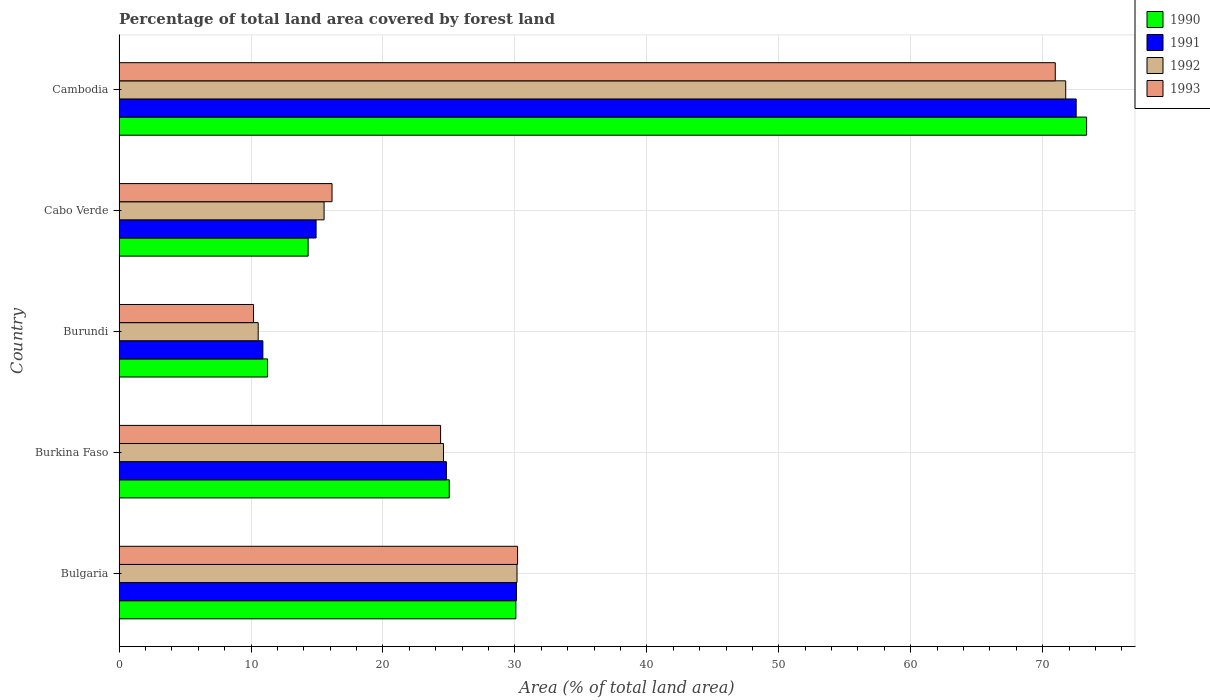How many different coloured bars are there?
Your answer should be compact. 4. What is the label of the 4th group of bars from the top?
Provide a short and direct response. Burkina Faso. In how many cases, is the number of bars for a given country not equal to the number of legend labels?
Ensure brevity in your answer.  0. What is the percentage of forest land in 1990 in Burundi?
Your answer should be very brief. 11.25. Across all countries, what is the maximum percentage of forest land in 1990?
Give a very brief answer. 73.33. Across all countries, what is the minimum percentage of forest land in 1992?
Offer a very short reply. 10.55. In which country was the percentage of forest land in 1993 maximum?
Keep it short and to the point. Cambodia. In which country was the percentage of forest land in 1991 minimum?
Ensure brevity in your answer.  Burundi. What is the total percentage of forest land in 1992 in the graph?
Your answer should be very brief. 152.58. What is the difference between the percentage of forest land in 1992 in Cabo Verde and that in Cambodia?
Offer a terse response. -56.21. What is the difference between the percentage of forest land in 1990 in Cabo Verde and the percentage of forest land in 1993 in Cambodia?
Make the answer very short. -56.62. What is the average percentage of forest land in 1990 per country?
Ensure brevity in your answer.  30.8. What is the difference between the percentage of forest land in 1993 and percentage of forest land in 1990 in Cabo Verde?
Your answer should be very brief. 1.81. What is the ratio of the percentage of forest land in 1990 in Cabo Verde to that in Cambodia?
Your answer should be very brief. 0.2. What is the difference between the highest and the second highest percentage of forest land in 1992?
Provide a short and direct response. 41.58. What is the difference between the highest and the lowest percentage of forest land in 1992?
Offer a terse response. 61.2. Is the sum of the percentage of forest land in 1993 in Burkina Faso and Cabo Verde greater than the maximum percentage of forest land in 1992 across all countries?
Your response must be concise. No. How many legend labels are there?
Your answer should be very brief. 4. How are the legend labels stacked?
Offer a terse response. Vertical. What is the title of the graph?
Offer a very short reply. Percentage of total land area covered by forest land. Does "1986" appear as one of the legend labels in the graph?
Provide a succinct answer. No. What is the label or title of the X-axis?
Provide a short and direct response. Area (% of total land area). What is the label or title of the Y-axis?
Provide a succinct answer. Country. What is the Area (% of total land area) of 1990 in Bulgaria?
Your answer should be compact. 30.07. What is the Area (% of total land area) in 1991 in Bulgaria?
Keep it short and to the point. 30.12. What is the Area (% of total land area) of 1992 in Bulgaria?
Your response must be concise. 30.16. What is the Area (% of total land area) of 1993 in Bulgaria?
Provide a succinct answer. 30.2. What is the Area (% of total land area) in 1990 in Burkina Faso?
Offer a very short reply. 25.03. What is the Area (% of total land area) in 1991 in Burkina Faso?
Your response must be concise. 24.81. What is the Area (% of total land area) of 1992 in Burkina Faso?
Make the answer very short. 24.59. What is the Area (% of total land area) in 1993 in Burkina Faso?
Provide a succinct answer. 24.37. What is the Area (% of total land area) of 1990 in Burundi?
Keep it short and to the point. 11.25. What is the Area (% of total land area) in 1991 in Burundi?
Make the answer very short. 10.9. What is the Area (% of total land area) in 1992 in Burundi?
Offer a very short reply. 10.55. What is the Area (% of total land area) in 1993 in Burundi?
Keep it short and to the point. 10.19. What is the Area (% of total land area) in 1990 in Cabo Verde?
Offer a very short reply. 14.33. What is the Area (% of total land area) of 1991 in Cabo Verde?
Provide a succinct answer. 14.93. What is the Area (% of total land area) of 1992 in Cabo Verde?
Offer a terse response. 15.54. What is the Area (% of total land area) in 1993 in Cabo Verde?
Offer a very short reply. 16.14. What is the Area (% of total land area) of 1990 in Cambodia?
Keep it short and to the point. 73.33. What is the Area (% of total land area) in 1991 in Cambodia?
Ensure brevity in your answer.  72.54. What is the Area (% of total land area) in 1992 in Cambodia?
Offer a terse response. 71.74. What is the Area (% of total land area) of 1993 in Cambodia?
Your response must be concise. 70.95. Across all countries, what is the maximum Area (% of total land area) in 1990?
Make the answer very short. 73.33. Across all countries, what is the maximum Area (% of total land area) in 1991?
Make the answer very short. 72.54. Across all countries, what is the maximum Area (% of total land area) in 1992?
Make the answer very short. 71.74. Across all countries, what is the maximum Area (% of total land area) of 1993?
Offer a very short reply. 70.95. Across all countries, what is the minimum Area (% of total land area) of 1990?
Your answer should be compact. 11.25. Across all countries, what is the minimum Area (% of total land area) of 1991?
Your answer should be very brief. 10.9. Across all countries, what is the minimum Area (% of total land area) in 1992?
Ensure brevity in your answer.  10.55. Across all countries, what is the minimum Area (% of total land area) in 1993?
Provide a short and direct response. 10.19. What is the total Area (% of total land area) of 1990 in the graph?
Your response must be concise. 154.01. What is the total Area (% of total land area) in 1991 in the graph?
Offer a very short reply. 153.29. What is the total Area (% of total land area) in 1992 in the graph?
Your answer should be very brief. 152.58. What is the total Area (% of total land area) in 1993 in the graph?
Offer a very short reply. 151.86. What is the difference between the Area (% of total land area) in 1990 in Bulgaria and that in Burkina Faso?
Ensure brevity in your answer.  5.05. What is the difference between the Area (% of total land area) of 1991 in Bulgaria and that in Burkina Faso?
Provide a short and direct response. 5.31. What is the difference between the Area (% of total land area) of 1992 in Bulgaria and that in Burkina Faso?
Offer a very short reply. 5.57. What is the difference between the Area (% of total land area) of 1993 in Bulgaria and that in Burkina Faso?
Your response must be concise. 5.83. What is the difference between the Area (% of total land area) in 1990 in Bulgaria and that in Burundi?
Keep it short and to the point. 18.82. What is the difference between the Area (% of total land area) of 1991 in Bulgaria and that in Burundi?
Offer a very short reply. 19.22. What is the difference between the Area (% of total land area) in 1992 in Bulgaria and that in Burundi?
Provide a succinct answer. 19.61. What is the difference between the Area (% of total land area) of 1993 in Bulgaria and that in Burundi?
Give a very brief answer. 20.01. What is the difference between the Area (% of total land area) of 1990 in Bulgaria and that in Cabo Verde?
Keep it short and to the point. 15.74. What is the difference between the Area (% of total land area) of 1991 in Bulgaria and that in Cabo Verde?
Your answer should be compact. 15.18. What is the difference between the Area (% of total land area) in 1992 in Bulgaria and that in Cabo Verde?
Ensure brevity in your answer.  14.62. What is the difference between the Area (% of total land area) in 1993 in Bulgaria and that in Cabo Verde?
Provide a succinct answer. 14.06. What is the difference between the Area (% of total land area) of 1990 in Bulgaria and that in Cambodia?
Provide a short and direct response. -43.26. What is the difference between the Area (% of total land area) in 1991 in Bulgaria and that in Cambodia?
Offer a very short reply. -42.42. What is the difference between the Area (% of total land area) of 1992 in Bulgaria and that in Cambodia?
Your answer should be compact. -41.58. What is the difference between the Area (% of total land area) in 1993 in Bulgaria and that in Cambodia?
Your answer should be compact. -40.75. What is the difference between the Area (% of total land area) in 1990 in Burkina Faso and that in Burundi?
Your answer should be compact. 13.77. What is the difference between the Area (% of total land area) of 1991 in Burkina Faso and that in Burundi?
Make the answer very short. 13.91. What is the difference between the Area (% of total land area) of 1992 in Burkina Faso and that in Burundi?
Your answer should be compact. 14.04. What is the difference between the Area (% of total land area) of 1993 in Burkina Faso and that in Burundi?
Give a very brief answer. 14.18. What is the difference between the Area (% of total land area) of 1990 in Burkina Faso and that in Cabo Verde?
Your response must be concise. 10.7. What is the difference between the Area (% of total land area) of 1991 in Burkina Faso and that in Cabo Verde?
Offer a terse response. 9.87. What is the difference between the Area (% of total land area) in 1992 in Burkina Faso and that in Cabo Verde?
Offer a very short reply. 9.05. What is the difference between the Area (% of total land area) of 1993 in Burkina Faso and that in Cabo Verde?
Provide a short and direct response. 8.23. What is the difference between the Area (% of total land area) in 1990 in Burkina Faso and that in Cambodia?
Keep it short and to the point. -48.3. What is the difference between the Area (% of total land area) in 1991 in Burkina Faso and that in Cambodia?
Keep it short and to the point. -47.73. What is the difference between the Area (% of total land area) in 1992 in Burkina Faso and that in Cambodia?
Keep it short and to the point. -47.16. What is the difference between the Area (% of total land area) of 1993 in Burkina Faso and that in Cambodia?
Ensure brevity in your answer.  -46.58. What is the difference between the Area (% of total land area) in 1990 in Burundi and that in Cabo Verde?
Give a very brief answer. -3.08. What is the difference between the Area (% of total land area) in 1991 in Burundi and that in Cabo Verde?
Give a very brief answer. -4.03. What is the difference between the Area (% of total land area) of 1992 in Burundi and that in Cabo Verde?
Your answer should be very brief. -4.99. What is the difference between the Area (% of total land area) of 1993 in Burundi and that in Cabo Verde?
Offer a terse response. -5.95. What is the difference between the Area (% of total land area) in 1990 in Burundi and that in Cambodia?
Provide a succinct answer. -62.07. What is the difference between the Area (% of total land area) of 1991 in Burundi and that in Cambodia?
Your answer should be very brief. -61.64. What is the difference between the Area (% of total land area) of 1992 in Burundi and that in Cambodia?
Ensure brevity in your answer.  -61.2. What is the difference between the Area (% of total land area) in 1993 in Burundi and that in Cambodia?
Ensure brevity in your answer.  -60.76. What is the difference between the Area (% of total land area) of 1990 in Cabo Verde and that in Cambodia?
Keep it short and to the point. -59. What is the difference between the Area (% of total land area) of 1991 in Cabo Verde and that in Cambodia?
Give a very brief answer. -57.6. What is the difference between the Area (% of total land area) in 1992 in Cabo Verde and that in Cambodia?
Your answer should be compact. -56.21. What is the difference between the Area (% of total land area) in 1993 in Cabo Verde and that in Cambodia?
Your answer should be compact. -54.81. What is the difference between the Area (% of total land area) of 1990 in Bulgaria and the Area (% of total land area) of 1991 in Burkina Faso?
Your answer should be compact. 5.27. What is the difference between the Area (% of total land area) in 1990 in Bulgaria and the Area (% of total land area) in 1992 in Burkina Faso?
Keep it short and to the point. 5.49. What is the difference between the Area (% of total land area) of 1990 in Bulgaria and the Area (% of total land area) of 1993 in Burkina Faso?
Provide a short and direct response. 5.7. What is the difference between the Area (% of total land area) of 1991 in Bulgaria and the Area (% of total land area) of 1992 in Burkina Faso?
Your answer should be compact. 5.53. What is the difference between the Area (% of total land area) in 1991 in Bulgaria and the Area (% of total land area) in 1993 in Burkina Faso?
Offer a terse response. 5.75. What is the difference between the Area (% of total land area) of 1992 in Bulgaria and the Area (% of total land area) of 1993 in Burkina Faso?
Provide a succinct answer. 5.79. What is the difference between the Area (% of total land area) in 1990 in Bulgaria and the Area (% of total land area) in 1991 in Burundi?
Your response must be concise. 19.17. What is the difference between the Area (% of total land area) of 1990 in Bulgaria and the Area (% of total land area) of 1992 in Burundi?
Provide a short and direct response. 19.53. What is the difference between the Area (% of total land area) in 1990 in Bulgaria and the Area (% of total land area) in 1993 in Burundi?
Make the answer very short. 19.88. What is the difference between the Area (% of total land area) in 1991 in Bulgaria and the Area (% of total land area) in 1992 in Burundi?
Your answer should be very brief. 19.57. What is the difference between the Area (% of total land area) in 1991 in Bulgaria and the Area (% of total land area) in 1993 in Burundi?
Keep it short and to the point. 19.93. What is the difference between the Area (% of total land area) in 1992 in Bulgaria and the Area (% of total land area) in 1993 in Burundi?
Your answer should be compact. 19.97. What is the difference between the Area (% of total land area) in 1990 in Bulgaria and the Area (% of total land area) in 1991 in Cabo Verde?
Provide a succinct answer. 15.14. What is the difference between the Area (% of total land area) in 1990 in Bulgaria and the Area (% of total land area) in 1992 in Cabo Verde?
Your response must be concise. 14.53. What is the difference between the Area (% of total land area) in 1990 in Bulgaria and the Area (% of total land area) in 1993 in Cabo Verde?
Give a very brief answer. 13.93. What is the difference between the Area (% of total land area) in 1991 in Bulgaria and the Area (% of total land area) in 1992 in Cabo Verde?
Ensure brevity in your answer.  14.58. What is the difference between the Area (% of total land area) of 1991 in Bulgaria and the Area (% of total land area) of 1993 in Cabo Verde?
Provide a short and direct response. 13.98. What is the difference between the Area (% of total land area) of 1992 in Bulgaria and the Area (% of total land area) of 1993 in Cabo Verde?
Your answer should be very brief. 14.02. What is the difference between the Area (% of total land area) in 1990 in Bulgaria and the Area (% of total land area) in 1991 in Cambodia?
Provide a short and direct response. -42.46. What is the difference between the Area (% of total land area) in 1990 in Bulgaria and the Area (% of total land area) in 1992 in Cambodia?
Your answer should be very brief. -41.67. What is the difference between the Area (% of total land area) in 1990 in Bulgaria and the Area (% of total land area) in 1993 in Cambodia?
Give a very brief answer. -40.88. What is the difference between the Area (% of total land area) of 1991 in Bulgaria and the Area (% of total land area) of 1992 in Cambodia?
Your answer should be very brief. -41.63. What is the difference between the Area (% of total land area) in 1991 in Bulgaria and the Area (% of total land area) in 1993 in Cambodia?
Your answer should be very brief. -40.84. What is the difference between the Area (% of total land area) in 1992 in Bulgaria and the Area (% of total land area) in 1993 in Cambodia?
Provide a succinct answer. -40.79. What is the difference between the Area (% of total land area) of 1990 in Burkina Faso and the Area (% of total land area) of 1991 in Burundi?
Your response must be concise. 14.13. What is the difference between the Area (% of total land area) of 1990 in Burkina Faso and the Area (% of total land area) of 1992 in Burundi?
Provide a short and direct response. 14.48. What is the difference between the Area (% of total land area) of 1990 in Burkina Faso and the Area (% of total land area) of 1993 in Burundi?
Provide a succinct answer. 14.83. What is the difference between the Area (% of total land area) in 1991 in Burkina Faso and the Area (% of total land area) in 1992 in Burundi?
Provide a short and direct response. 14.26. What is the difference between the Area (% of total land area) of 1991 in Burkina Faso and the Area (% of total land area) of 1993 in Burundi?
Offer a terse response. 14.62. What is the difference between the Area (% of total land area) of 1992 in Burkina Faso and the Area (% of total land area) of 1993 in Burundi?
Keep it short and to the point. 14.4. What is the difference between the Area (% of total land area) of 1990 in Burkina Faso and the Area (% of total land area) of 1991 in Cabo Verde?
Ensure brevity in your answer.  10.09. What is the difference between the Area (% of total land area) of 1990 in Burkina Faso and the Area (% of total land area) of 1992 in Cabo Verde?
Make the answer very short. 9.49. What is the difference between the Area (% of total land area) of 1990 in Burkina Faso and the Area (% of total land area) of 1993 in Cabo Verde?
Provide a succinct answer. 8.88. What is the difference between the Area (% of total land area) in 1991 in Burkina Faso and the Area (% of total land area) in 1992 in Cabo Verde?
Ensure brevity in your answer.  9.27. What is the difference between the Area (% of total land area) in 1991 in Burkina Faso and the Area (% of total land area) in 1993 in Cabo Verde?
Give a very brief answer. 8.67. What is the difference between the Area (% of total land area) of 1992 in Burkina Faso and the Area (% of total land area) of 1993 in Cabo Verde?
Offer a very short reply. 8.45. What is the difference between the Area (% of total land area) of 1990 in Burkina Faso and the Area (% of total land area) of 1991 in Cambodia?
Your response must be concise. -47.51. What is the difference between the Area (% of total land area) in 1990 in Burkina Faso and the Area (% of total land area) in 1992 in Cambodia?
Provide a succinct answer. -46.72. What is the difference between the Area (% of total land area) in 1990 in Burkina Faso and the Area (% of total land area) in 1993 in Cambodia?
Keep it short and to the point. -45.93. What is the difference between the Area (% of total land area) in 1991 in Burkina Faso and the Area (% of total land area) in 1992 in Cambodia?
Offer a terse response. -46.94. What is the difference between the Area (% of total land area) of 1991 in Burkina Faso and the Area (% of total land area) of 1993 in Cambodia?
Provide a succinct answer. -46.15. What is the difference between the Area (% of total land area) of 1992 in Burkina Faso and the Area (% of total land area) of 1993 in Cambodia?
Give a very brief answer. -46.37. What is the difference between the Area (% of total land area) in 1990 in Burundi and the Area (% of total land area) in 1991 in Cabo Verde?
Provide a succinct answer. -3.68. What is the difference between the Area (% of total land area) in 1990 in Burundi and the Area (% of total land area) in 1992 in Cabo Verde?
Your response must be concise. -4.28. What is the difference between the Area (% of total land area) of 1990 in Burundi and the Area (% of total land area) of 1993 in Cabo Verde?
Ensure brevity in your answer.  -4.89. What is the difference between the Area (% of total land area) in 1991 in Burundi and the Area (% of total land area) in 1992 in Cabo Verde?
Give a very brief answer. -4.64. What is the difference between the Area (% of total land area) in 1991 in Burundi and the Area (% of total land area) in 1993 in Cabo Verde?
Make the answer very short. -5.24. What is the difference between the Area (% of total land area) in 1992 in Burundi and the Area (% of total land area) in 1993 in Cabo Verde?
Make the answer very short. -5.6. What is the difference between the Area (% of total land area) of 1990 in Burundi and the Area (% of total land area) of 1991 in Cambodia?
Your response must be concise. -61.28. What is the difference between the Area (% of total land area) of 1990 in Burundi and the Area (% of total land area) of 1992 in Cambodia?
Your answer should be very brief. -60.49. What is the difference between the Area (% of total land area) in 1990 in Burundi and the Area (% of total land area) in 1993 in Cambodia?
Your answer should be compact. -59.7. What is the difference between the Area (% of total land area) in 1991 in Burundi and the Area (% of total land area) in 1992 in Cambodia?
Offer a terse response. -60.85. What is the difference between the Area (% of total land area) of 1991 in Burundi and the Area (% of total land area) of 1993 in Cambodia?
Offer a terse response. -60.05. What is the difference between the Area (% of total land area) of 1992 in Burundi and the Area (% of total land area) of 1993 in Cambodia?
Your response must be concise. -60.41. What is the difference between the Area (% of total land area) in 1990 in Cabo Verde and the Area (% of total land area) in 1991 in Cambodia?
Make the answer very short. -58.21. What is the difference between the Area (% of total land area) of 1990 in Cabo Verde and the Area (% of total land area) of 1992 in Cambodia?
Keep it short and to the point. -57.41. What is the difference between the Area (% of total land area) in 1990 in Cabo Verde and the Area (% of total land area) in 1993 in Cambodia?
Ensure brevity in your answer.  -56.62. What is the difference between the Area (% of total land area) in 1991 in Cabo Verde and the Area (% of total land area) in 1992 in Cambodia?
Your response must be concise. -56.81. What is the difference between the Area (% of total land area) of 1991 in Cabo Verde and the Area (% of total land area) of 1993 in Cambodia?
Make the answer very short. -56.02. What is the difference between the Area (% of total land area) of 1992 in Cabo Verde and the Area (% of total land area) of 1993 in Cambodia?
Offer a very short reply. -55.41. What is the average Area (% of total land area) of 1990 per country?
Make the answer very short. 30.8. What is the average Area (% of total land area) of 1991 per country?
Offer a very short reply. 30.66. What is the average Area (% of total land area) of 1992 per country?
Make the answer very short. 30.52. What is the average Area (% of total land area) in 1993 per country?
Offer a very short reply. 30.37. What is the difference between the Area (% of total land area) of 1990 and Area (% of total land area) of 1991 in Bulgaria?
Your answer should be compact. -0.04. What is the difference between the Area (% of total land area) in 1990 and Area (% of total land area) in 1992 in Bulgaria?
Ensure brevity in your answer.  -0.09. What is the difference between the Area (% of total land area) in 1990 and Area (% of total land area) in 1993 in Bulgaria?
Ensure brevity in your answer.  -0.13. What is the difference between the Area (% of total land area) in 1991 and Area (% of total land area) in 1992 in Bulgaria?
Make the answer very short. -0.04. What is the difference between the Area (% of total land area) in 1991 and Area (% of total land area) in 1993 in Bulgaria?
Keep it short and to the point. -0.09. What is the difference between the Area (% of total land area) of 1992 and Area (% of total land area) of 1993 in Bulgaria?
Ensure brevity in your answer.  -0.04. What is the difference between the Area (% of total land area) of 1990 and Area (% of total land area) of 1991 in Burkina Faso?
Ensure brevity in your answer.  0.22. What is the difference between the Area (% of total land area) in 1990 and Area (% of total land area) in 1992 in Burkina Faso?
Make the answer very short. 0.44. What is the difference between the Area (% of total land area) in 1990 and Area (% of total land area) in 1993 in Burkina Faso?
Your answer should be very brief. 0.66. What is the difference between the Area (% of total land area) of 1991 and Area (% of total land area) of 1992 in Burkina Faso?
Make the answer very short. 0.22. What is the difference between the Area (% of total land area) in 1991 and Area (% of total land area) in 1993 in Burkina Faso?
Your answer should be compact. 0.44. What is the difference between the Area (% of total land area) of 1992 and Area (% of total land area) of 1993 in Burkina Faso?
Offer a terse response. 0.22. What is the difference between the Area (% of total land area) in 1990 and Area (% of total land area) in 1991 in Burundi?
Make the answer very short. 0.35. What is the difference between the Area (% of total land area) in 1990 and Area (% of total land area) in 1992 in Burundi?
Make the answer very short. 0.71. What is the difference between the Area (% of total land area) of 1990 and Area (% of total land area) of 1993 in Burundi?
Your response must be concise. 1.06. What is the difference between the Area (% of total land area) of 1991 and Area (% of total land area) of 1992 in Burundi?
Your answer should be compact. 0.35. What is the difference between the Area (% of total land area) of 1991 and Area (% of total land area) of 1993 in Burundi?
Provide a short and direct response. 0.71. What is the difference between the Area (% of total land area) of 1992 and Area (% of total land area) of 1993 in Burundi?
Keep it short and to the point. 0.35. What is the difference between the Area (% of total land area) in 1990 and Area (% of total land area) in 1991 in Cabo Verde?
Give a very brief answer. -0.6. What is the difference between the Area (% of total land area) in 1990 and Area (% of total land area) in 1992 in Cabo Verde?
Keep it short and to the point. -1.21. What is the difference between the Area (% of total land area) in 1990 and Area (% of total land area) in 1993 in Cabo Verde?
Provide a short and direct response. -1.81. What is the difference between the Area (% of total land area) of 1991 and Area (% of total land area) of 1992 in Cabo Verde?
Offer a terse response. -0.61. What is the difference between the Area (% of total land area) in 1991 and Area (% of total land area) in 1993 in Cabo Verde?
Provide a succinct answer. -1.21. What is the difference between the Area (% of total land area) of 1992 and Area (% of total land area) of 1993 in Cabo Verde?
Keep it short and to the point. -0.6. What is the difference between the Area (% of total land area) of 1990 and Area (% of total land area) of 1991 in Cambodia?
Your answer should be compact. 0.79. What is the difference between the Area (% of total land area) in 1990 and Area (% of total land area) in 1992 in Cambodia?
Offer a very short reply. 1.58. What is the difference between the Area (% of total land area) in 1990 and Area (% of total land area) in 1993 in Cambodia?
Your answer should be very brief. 2.38. What is the difference between the Area (% of total land area) of 1991 and Area (% of total land area) of 1992 in Cambodia?
Provide a succinct answer. 0.79. What is the difference between the Area (% of total land area) in 1991 and Area (% of total land area) in 1993 in Cambodia?
Provide a succinct answer. 1.58. What is the difference between the Area (% of total land area) in 1992 and Area (% of total land area) in 1993 in Cambodia?
Ensure brevity in your answer.  0.79. What is the ratio of the Area (% of total land area) in 1990 in Bulgaria to that in Burkina Faso?
Ensure brevity in your answer.  1.2. What is the ratio of the Area (% of total land area) of 1991 in Bulgaria to that in Burkina Faso?
Make the answer very short. 1.21. What is the ratio of the Area (% of total land area) in 1992 in Bulgaria to that in Burkina Faso?
Your answer should be compact. 1.23. What is the ratio of the Area (% of total land area) in 1993 in Bulgaria to that in Burkina Faso?
Offer a terse response. 1.24. What is the ratio of the Area (% of total land area) in 1990 in Bulgaria to that in Burundi?
Offer a terse response. 2.67. What is the ratio of the Area (% of total land area) of 1991 in Bulgaria to that in Burundi?
Give a very brief answer. 2.76. What is the ratio of the Area (% of total land area) of 1992 in Bulgaria to that in Burundi?
Keep it short and to the point. 2.86. What is the ratio of the Area (% of total land area) in 1993 in Bulgaria to that in Burundi?
Make the answer very short. 2.96. What is the ratio of the Area (% of total land area) of 1990 in Bulgaria to that in Cabo Verde?
Offer a terse response. 2.1. What is the ratio of the Area (% of total land area) of 1991 in Bulgaria to that in Cabo Verde?
Offer a terse response. 2.02. What is the ratio of the Area (% of total land area) of 1992 in Bulgaria to that in Cabo Verde?
Offer a very short reply. 1.94. What is the ratio of the Area (% of total land area) of 1993 in Bulgaria to that in Cabo Verde?
Offer a very short reply. 1.87. What is the ratio of the Area (% of total land area) of 1990 in Bulgaria to that in Cambodia?
Make the answer very short. 0.41. What is the ratio of the Area (% of total land area) in 1991 in Bulgaria to that in Cambodia?
Provide a short and direct response. 0.42. What is the ratio of the Area (% of total land area) of 1992 in Bulgaria to that in Cambodia?
Give a very brief answer. 0.42. What is the ratio of the Area (% of total land area) of 1993 in Bulgaria to that in Cambodia?
Provide a short and direct response. 0.43. What is the ratio of the Area (% of total land area) of 1990 in Burkina Faso to that in Burundi?
Your response must be concise. 2.22. What is the ratio of the Area (% of total land area) of 1991 in Burkina Faso to that in Burundi?
Offer a terse response. 2.28. What is the ratio of the Area (% of total land area) in 1992 in Burkina Faso to that in Burundi?
Offer a very short reply. 2.33. What is the ratio of the Area (% of total land area) in 1993 in Burkina Faso to that in Burundi?
Give a very brief answer. 2.39. What is the ratio of the Area (% of total land area) in 1990 in Burkina Faso to that in Cabo Verde?
Provide a short and direct response. 1.75. What is the ratio of the Area (% of total land area) of 1991 in Burkina Faso to that in Cabo Verde?
Give a very brief answer. 1.66. What is the ratio of the Area (% of total land area) in 1992 in Burkina Faso to that in Cabo Verde?
Keep it short and to the point. 1.58. What is the ratio of the Area (% of total land area) of 1993 in Burkina Faso to that in Cabo Verde?
Provide a short and direct response. 1.51. What is the ratio of the Area (% of total land area) in 1990 in Burkina Faso to that in Cambodia?
Your answer should be compact. 0.34. What is the ratio of the Area (% of total land area) of 1991 in Burkina Faso to that in Cambodia?
Your answer should be compact. 0.34. What is the ratio of the Area (% of total land area) in 1992 in Burkina Faso to that in Cambodia?
Offer a very short reply. 0.34. What is the ratio of the Area (% of total land area) in 1993 in Burkina Faso to that in Cambodia?
Your answer should be very brief. 0.34. What is the ratio of the Area (% of total land area) of 1990 in Burundi to that in Cabo Verde?
Keep it short and to the point. 0.79. What is the ratio of the Area (% of total land area) in 1991 in Burundi to that in Cabo Verde?
Offer a terse response. 0.73. What is the ratio of the Area (% of total land area) of 1992 in Burundi to that in Cabo Verde?
Keep it short and to the point. 0.68. What is the ratio of the Area (% of total land area) in 1993 in Burundi to that in Cabo Verde?
Your answer should be compact. 0.63. What is the ratio of the Area (% of total land area) in 1990 in Burundi to that in Cambodia?
Offer a very short reply. 0.15. What is the ratio of the Area (% of total land area) in 1991 in Burundi to that in Cambodia?
Ensure brevity in your answer.  0.15. What is the ratio of the Area (% of total land area) of 1992 in Burundi to that in Cambodia?
Your answer should be very brief. 0.15. What is the ratio of the Area (% of total land area) in 1993 in Burundi to that in Cambodia?
Make the answer very short. 0.14. What is the ratio of the Area (% of total land area) in 1990 in Cabo Verde to that in Cambodia?
Provide a succinct answer. 0.2. What is the ratio of the Area (% of total land area) of 1991 in Cabo Verde to that in Cambodia?
Offer a very short reply. 0.21. What is the ratio of the Area (% of total land area) of 1992 in Cabo Verde to that in Cambodia?
Make the answer very short. 0.22. What is the ratio of the Area (% of total land area) of 1993 in Cabo Verde to that in Cambodia?
Make the answer very short. 0.23. What is the difference between the highest and the second highest Area (% of total land area) of 1990?
Make the answer very short. 43.26. What is the difference between the highest and the second highest Area (% of total land area) of 1991?
Ensure brevity in your answer.  42.42. What is the difference between the highest and the second highest Area (% of total land area) of 1992?
Your response must be concise. 41.58. What is the difference between the highest and the second highest Area (% of total land area) in 1993?
Offer a terse response. 40.75. What is the difference between the highest and the lowest Area (% of total land area) in 1990?
Provide a short and direct response. 62.07. What is the difference between the highest and the lowest Area (% of total land area) of 1991?
Keep it short and to the point. 61.64. What is the difference between the highest and the lowest Area (% of total land area) of 1992?
Offer a terse response. 61.2. What is the difference between the highest and the lowest Area (% of total land area) in 1993?
Make the answer very short. 60.76. 